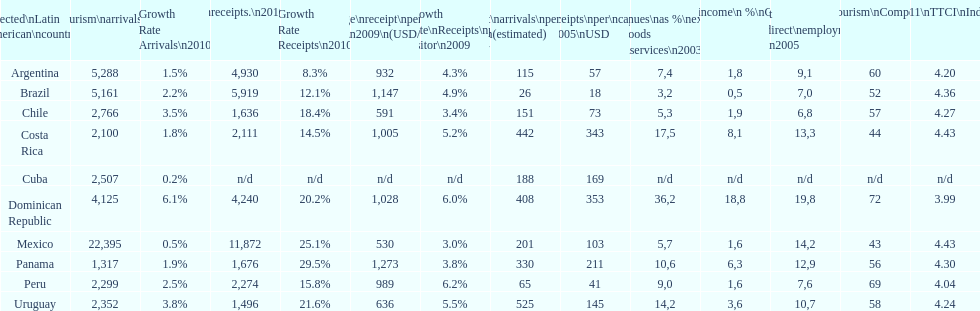Tourism income in latin american countries in 2003 was at most what percentage of gdp? 18,8. 